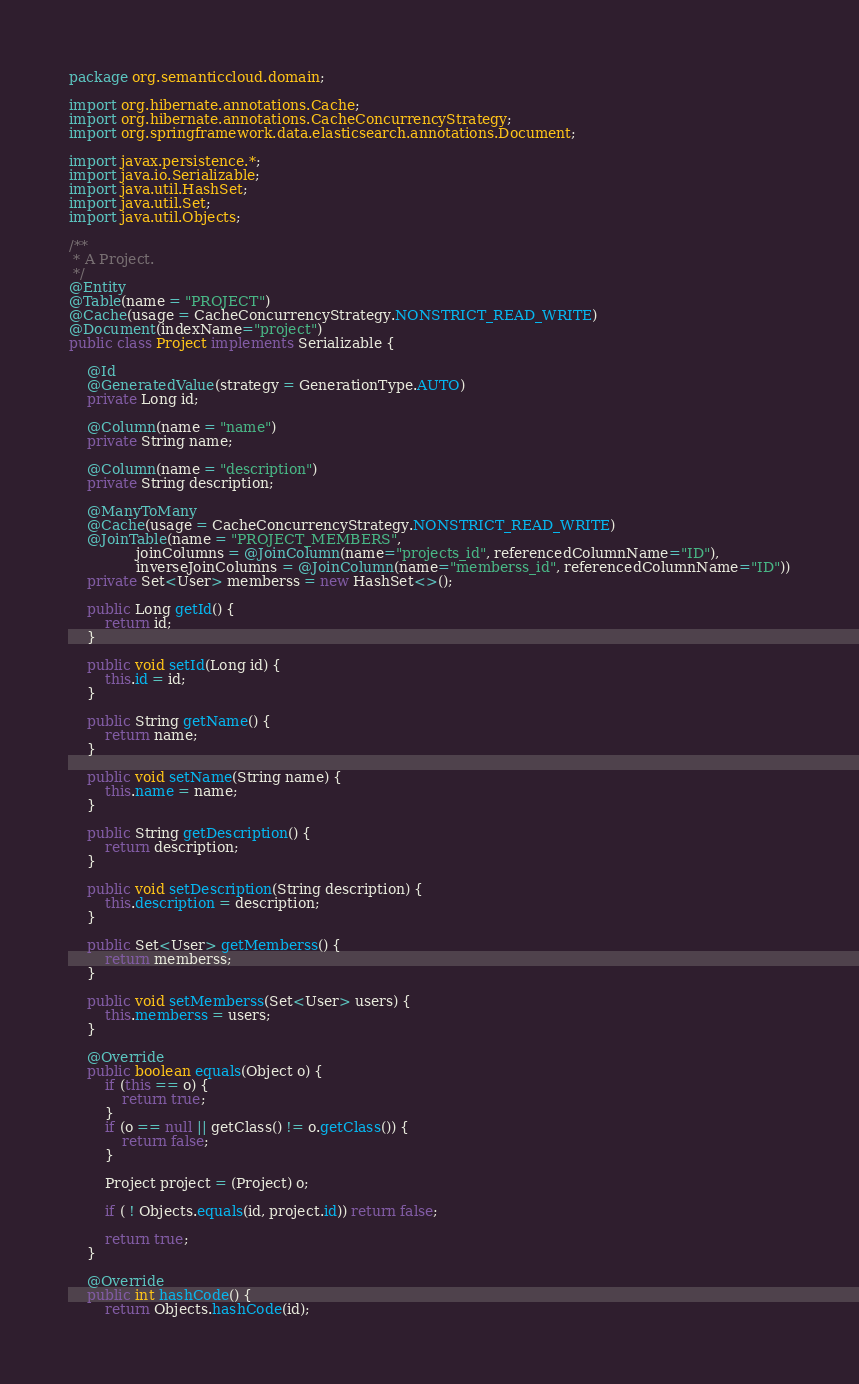Convert code to text. <code><loc_0><loc_0><loc_500><loc_500><_Java_>package org.semanticcloud.domain;

import org.hibernate.annotations.Cache;
import org.hibernate.annotations.CacheConcurrencyStrategy;
import org.springframework.data.elasticsearch.annotations.Document;

import javax.persistence.*;
import java.io.Serializable;
import java.util.HashSet;
import java.util.Set;
import java.util.Objects;

/**
 * A Project.
 */
@Entity
@Table(name = "PROJECT")
@Cache(usage = CacheConcurrencyStrategy.NONSTRICT_READ_WRITE)
@Document(indexName="project")
public class Project implements Serializable {

    @Id
    @GeneratedValue(strategy = GenerationType.AUTO)
    private Long id;
    
    @Column(name = "name")
    private String name;
    
    @Column(name = "description")
    private String description;

    @ManyToMany
    @Cache(usage = CacheConcurrencyStrategy.NONSTRICT_READ_WRITE)
    @JoinTable(name = "PROJECT_MEMBERS",
               joinColumns = @JoinColumn(name="projects_id", referencedColumnName="ID"),
               inverseJoinColumns = @JoinColumn(name="memberss_id", referencedColumnName="ID"))
    private Set<User> memberss = new HashSet<>();

    public Long getId() {
        return id;
    }

    public void setId(Long id) {
        this.id = id;
    }

    public String getName() {
        return name;
    }

    public void setName(String name) {
        this.name = name;
    }

    public String getDescription() {
        return description;
    }

    public void setDescription(String description) {
        this.description = description;
    }

    public Set<User> getMemberss() {
        return memberss;
    }

    public void setMemberss(Set<User> users) {
        this.memberss = users;
    }

    @Override
    public boolean equals(Object o) {
        if (this == o) {
            return true;
        }
        if (o == null || getClass() != o.getClass()) {
            return false;
        }

        Project project = (Project) o;

        if ( ! Objects.equals(id, project.id)) return false;

        return true;
    }

    @Override
    public int hashCode() {
        return Objects.hashCode(id);</code> 